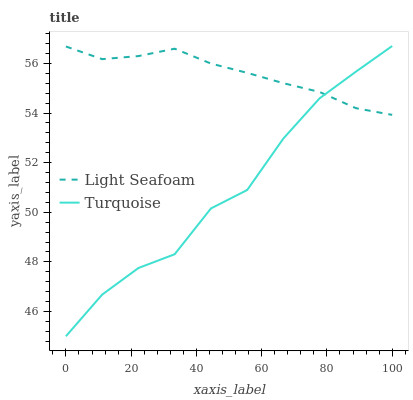Does Turquoise have the minimum area under the curve?
Answer yes or no. Yes. Does Light Seafoam have the maximum area under the curve?
Answer yes or no. Yes. Does Light Seafoam have the minimum area under the curve?
Answer yes or no. No. Is Light Seafoam the smoothest?
Answer yes or no. Yes. Is Turquoise the roughest?
Answer yes or no. Yes. Is Light Seafoam the roughest?
Answer yes or no. No. Does Turquoise have the lowest value?
Answer yes or no. Yes. Does Light Seafoam have the lowest value?
Answer yes or no. No. Does Turquoise have the highest value?
Answer yes or no. Yes. Does Light Seafoam have the highest value?
Answer yes or no. No. Does Light Seafoam intersect Turquoise?
Answer yes or no. Yes. Is Light Seafoam less than Turquoise?
Answer yes or no. No. Is Light Seafoam greater than Turquoise?
Answer yes or no. No. 